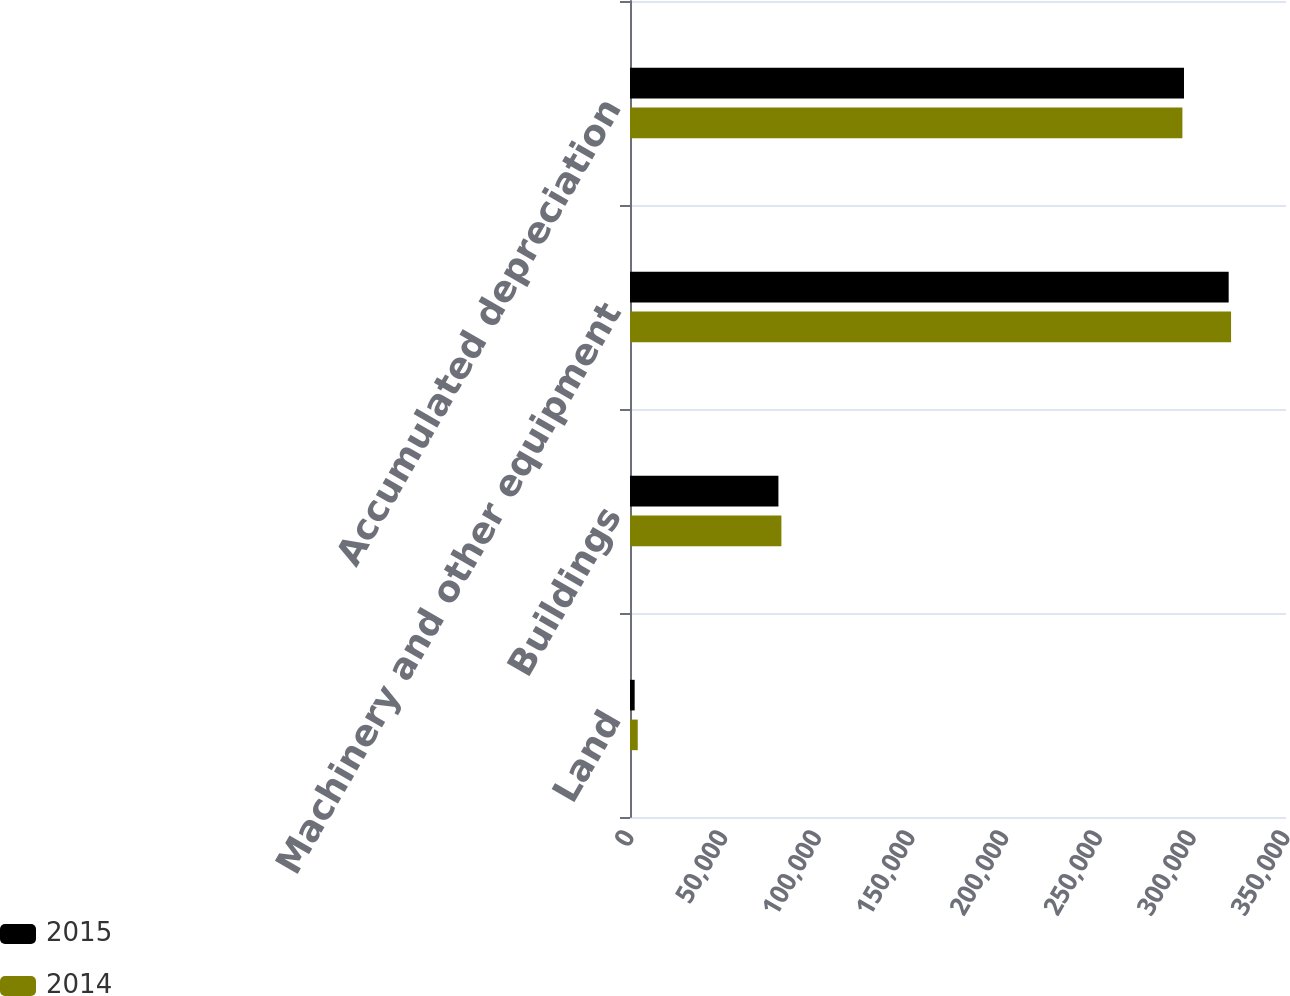<chart> <loc_0><loc_0><loc_500><loc_500><stacked_bar_chart><ecel><fcel>Land<fcel>Buildings<fcel>Machinery and other equipment<fcel>Accumulated depreciation<nl><fcel>2015<fcel>2488<fcel>79182<fcel>319416<fcel>295576<nl><fcel>2014<fcel>4130<fcel>80775<fcel>320697<fcel>294726<nl></chart> 